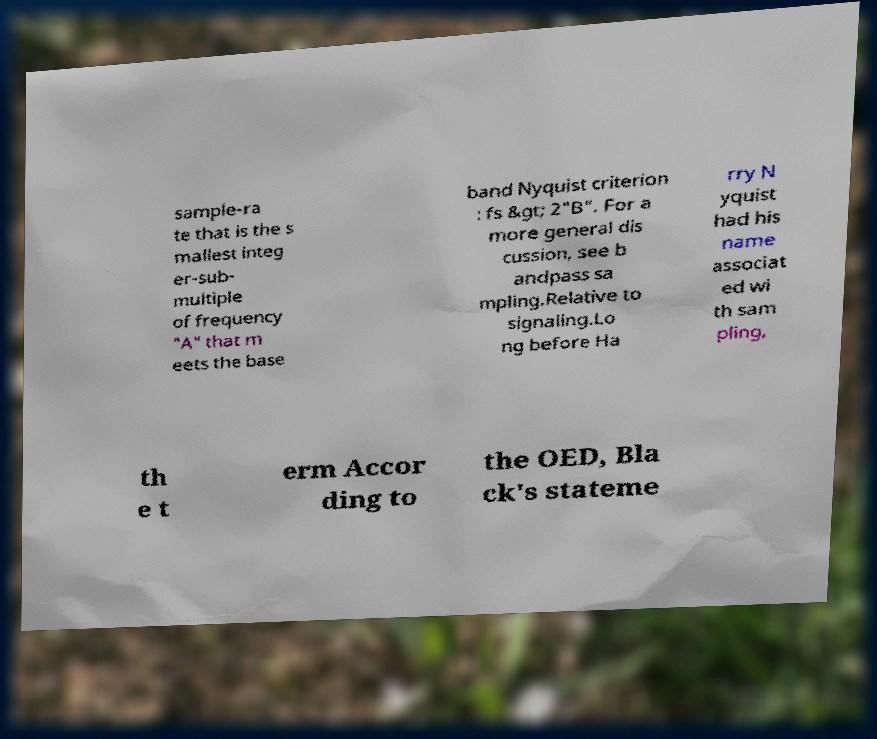There's text embedded in this image that I need extracted. Can you transcribe it verbatim? sample-ra te that is the s mallest integ er-sub- multiple of frequency "A" that m eets the base band Nyquist criterion : fs &gt; 2"B". For a more general dis cussion, see b andpass sa mpling.Relative to signaling.Lo ng before Ha rry N yquist had his name associat ed wi th sam pling, th e t erm Accor ding to the OED, Bla ck's stateme 